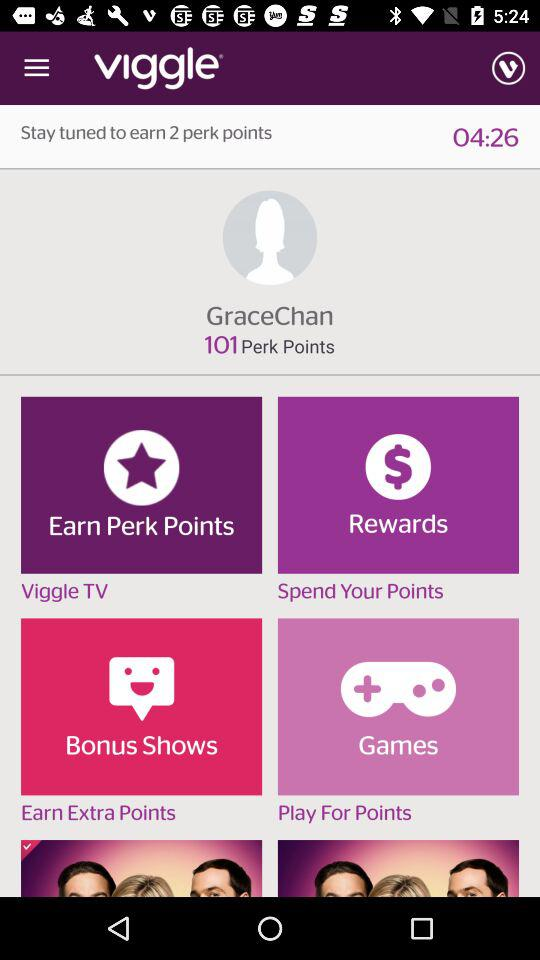What is the name of the application? The name of the application is "viggle". 